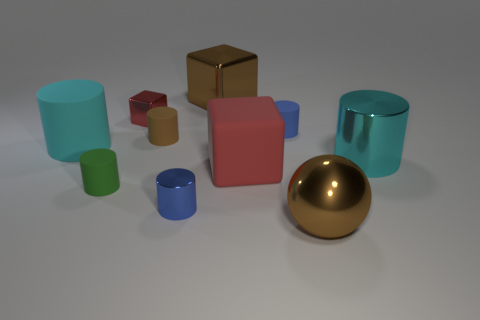Subtract all green cylinders. How many cylinders are left? 5 Subtract all brown cylinders. How many cylinders are left? 5 Subtract all brown cylinders. Subtract all yellow spheres. How many cylinders are left? 5 Subtract all cubes. How many objects are left? 7 Add 3 red matte objects. How many red matte objects exist? 4 Subtract 0 blue blocks. How many objects are left? 10 Subtract all red metal blocks. Subtract all cyan metal cylinders. How many objects are left? 8 Add 4 brown shiny spheres. How many brown shiny spheres are left? 5 